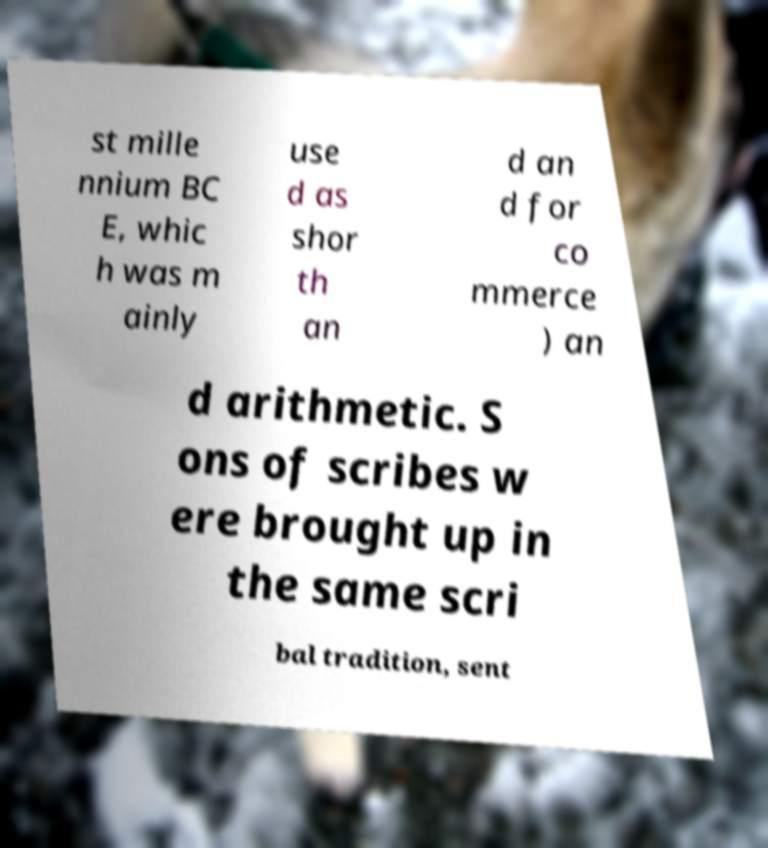What messages or text are displayed in this image? I need them in a readable, typed format. st mille nnium BC E, whic h was m ainly use d as shor th an d an d for co mmerce ) an d arithmetic. S ons of scribes w ere brought up in the same scri bal tradition, sent 